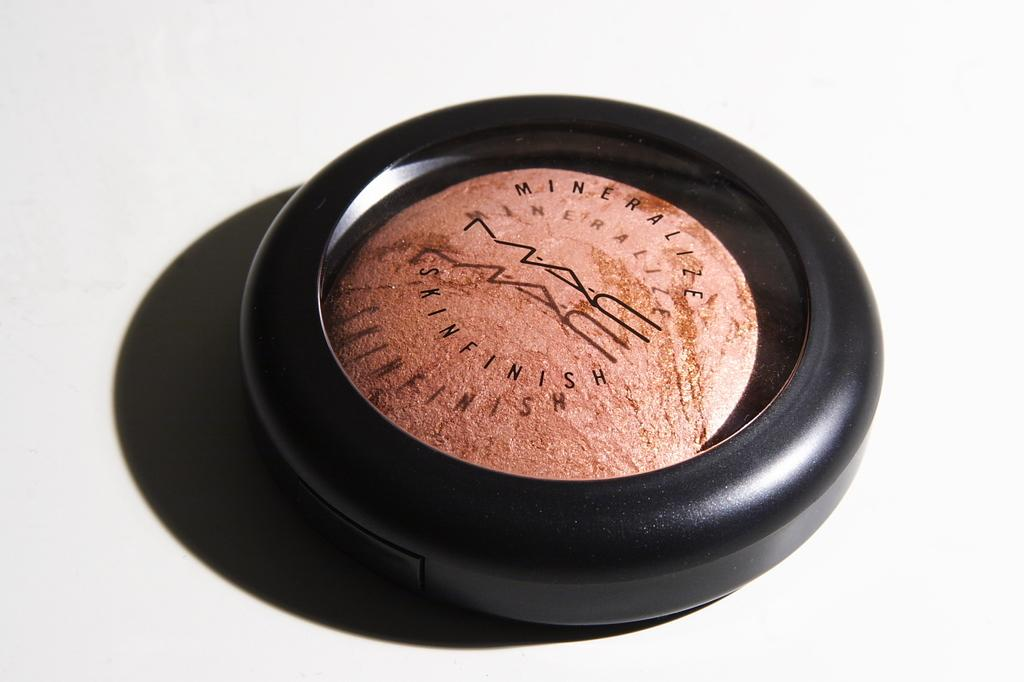What object is present in the image? There is a compact in the image. What is inside the compact? The compact contains rose gold powder. Is there a letter written by a bat in the image? There is no letter or bat present in the image. Can you see a cat playing with the compact in the image? There is no cat present in the image. 